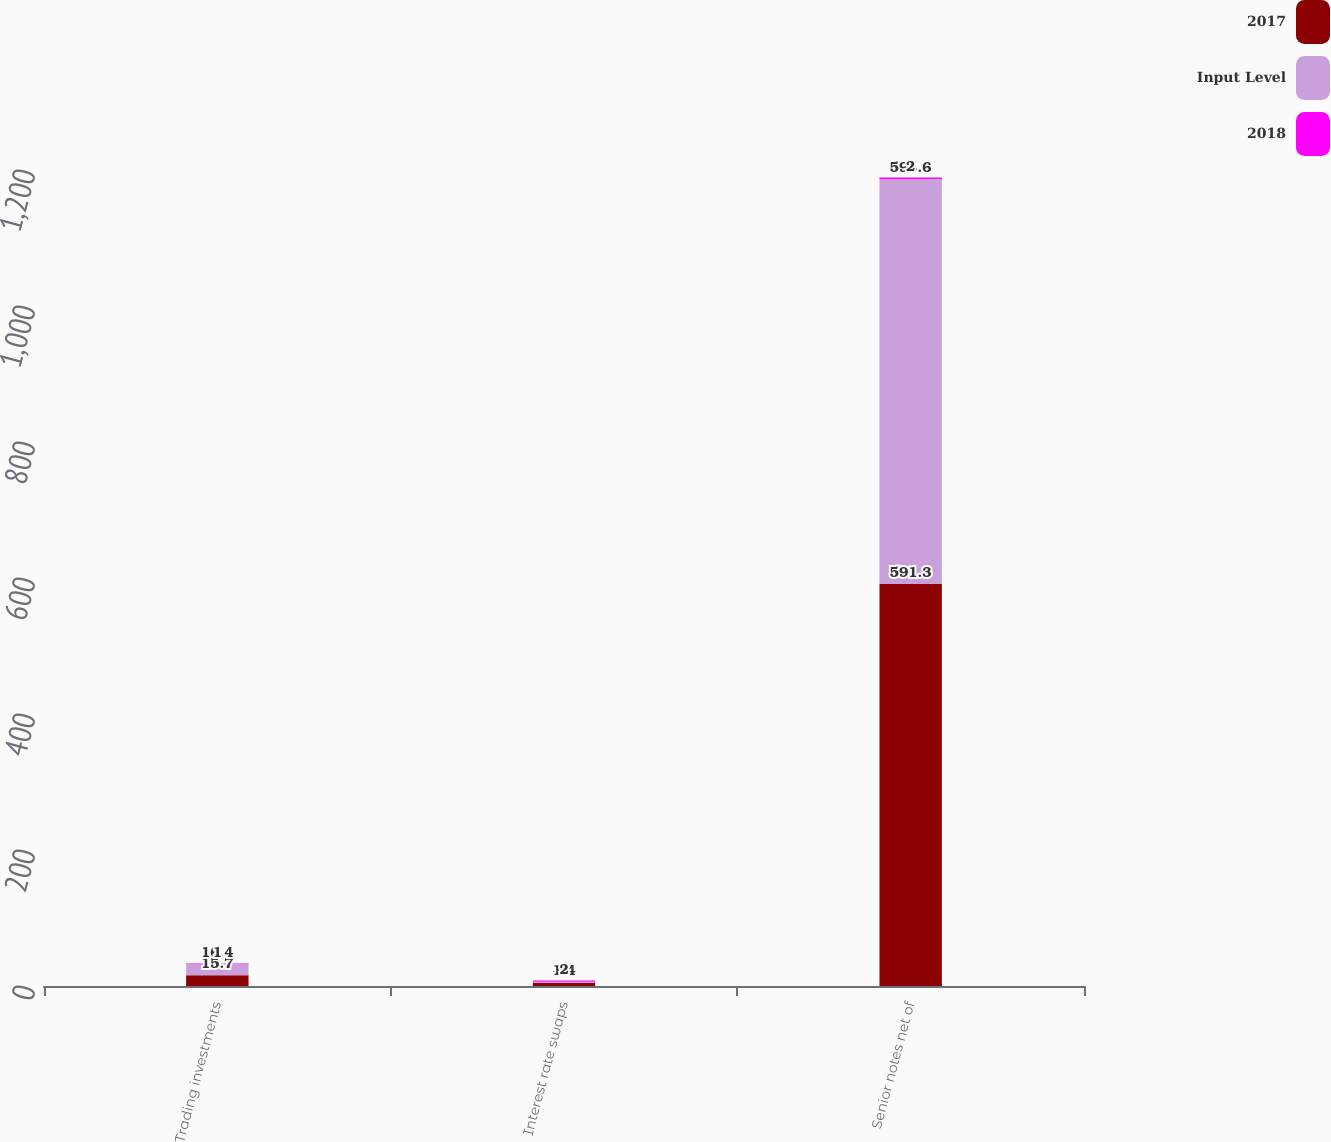<chart> <loc_0><loc_0><loc_500><loc_500><stacked_bar_chart><ecel><fcel>Trading investments<fcel>Interest rate swaps<fcel>Senior notes net of<nl><fcel>2017<fcel>15.7<fcel>4.8<fcel>591.3<nl><fcel>Input Level<fcel>16.4<fcel>1.4<fcel>595.6<nl><fcel>2018<fcel>1<fcel>2<fcel>2<nl></chart> 